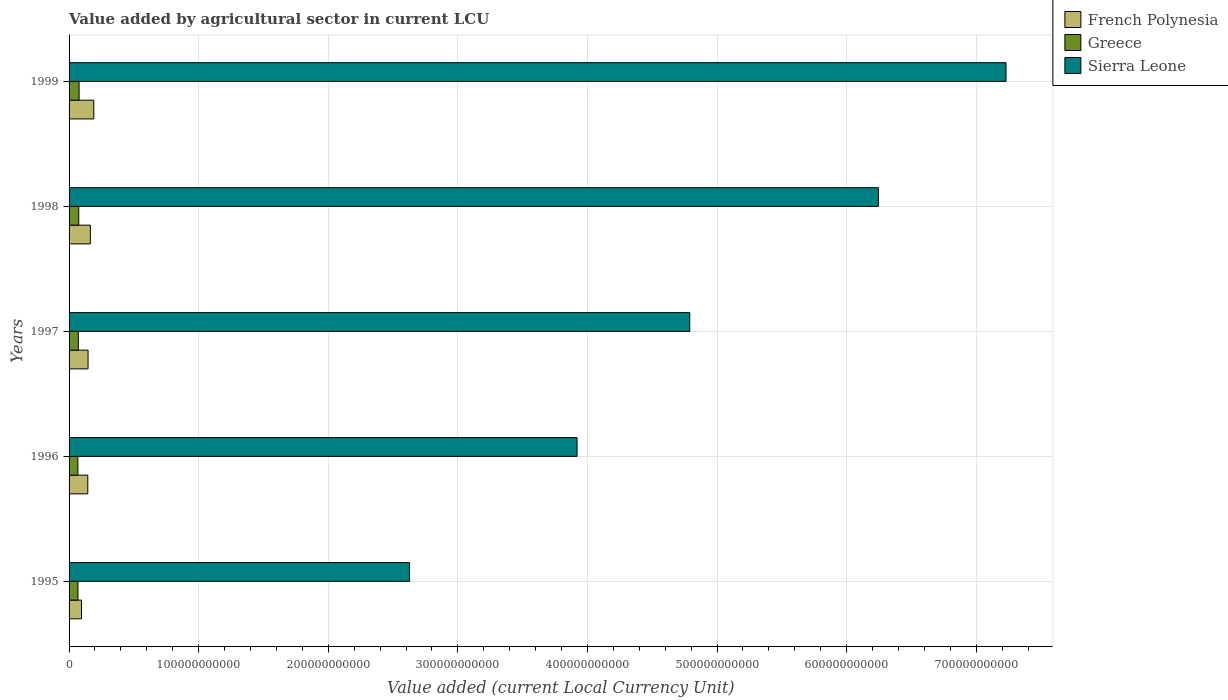Are the number of bars on each tick of the Y-axis equal?
Keep it short and to the point. Yes. How many bars are there on the 3rd tick from the bottom?
Your answer should be very brief. 3. What is the label of the 4th group of bars from the top?
Make the answer very short. 1996. In how many cases, is the number of bars for a given year not equal to the number of legend labels?
Provide a succinct answer. 0. What is the value added by agricultural sector in Greece in 1996?
Your answer should be compact. 6.78e+09. Across all years, what is the maximum value added by agricultural sector in Greece?
Your answer should be very brief. 7.74e+09. Across all years, what is the minimum value added by agricultural sector in Greece?
Keep it short and to the point. 6.78e+09. In which year was the value added by agricultural sector in Sierra Leone maximum?
Your response must be concise. 1999. In which year was the value added by agricultural sector in Greece minimum?
Your answer should be compact. 1996. What is the total value added by agricultural sector in Greece in the graph?
Give a very brief answer. 3.60e+1. What is the difference between the value added by agricultural sector in Greece in 1995 and that in 1997?
Ensure brevity in your answer.  -2.96e+08. What is the difference between the value added by agricultural sector in Greece in 1996 and the value added by agricultural sector in French Polynesia in 1998?
Your answer should be very brief. -9.64e+09. What is the average value added by agricultural sector in Greece per year?
Provide a succinct answer. 7.20e+09. In the year 1998, what is the difference between the value added by agricultural sector in Sierra Leone and value added by agricultural sector in French Polynesia?
Your answer should be very brief. 6.08e+11. What is the ratio of the value added by agricultural sector in Sierra Leone in 1996 to that in 1998?
Provide a succinct answer. 0.63. Is the difference between the value added by agricultural sector in Sierra Leone in 1996 and 1997 greater than the difference between the value added by agricultural sector in French Polynesia in 1996 and 1997?
Offer a terse response. No. What is the difference between the highest and the second highest value added by agricultural sector in Greece?
Your response must be concise. 2.66e+08. What is the difference between the highest and the lowest value added by agricultural sector in Sierra Leone?
Provide a succinct answer. 4.60e+11. Is the sum of the value added by agricultural sector in Greece in 1996 and 1999 greater than the maximum value added by agricultural sector in Sierra Leone across all years?
Ensure brevity in your answer.  No. What does the 3rd bar from the top in 1999 represents?
Your response must be concise. French Polynesia. What does the 1st bar from the bottom in 1997 represents?
Offer a terse response. French Polynesia. Is it the case that in every year, the sum of the value added by agricultural sector in French Polynesia and value added by agricultural sector in Greece is greater than the value added by agricultural sector in Sierra Leone?
Provide a succinct answer. No. Are all the bars in the graph horizontal?
Provide a succinct answer. Yes. How many years are there in the graph?
Provide a short and direct response. 5. What is the difference between two consecutive major ticks on the X-axis?
Make the answer very short. 1.00e+11. Are the values on the major ticks of X-axis written in scientific E-notation?
Your answer should be compact. No. Does the graph contain any zero values?
Ensure brevity in your answer.  No. Does the graph contain grids?
Your answer should be compact. Yes. Where does the legend appear in the graph?
Provide a succinct answer. Top right. What is the title of the graph?
Make the answer very short. Value added by agricultural sector in current LCU. What is the label or title of the X-axis?
Offer a terse response. Value added (current Local Currency Unit). What is the label or title of the Y-axis?
Offer a very short reply. Years. What is the Value added (current Local Currency Unit) in French Polynesia in 1995?
Offer a very short reply. 9.59e+09. What is the Value added (current Local Currency Unit) of Greece in 1995?
Offer a terse response. 6.86e+09. What is the Value added (current Local Currency Unit) of Sierra Leone in 1995?
Ensure brevity in your answer.  2.63e+11. What is the Value added (current Local Currency Unit) of French Polynesia in 1996?
Ensure brevity in your answer.  1.45e+1. What is the Value added (current Local Currency Unit) of Greece in 1996?
Provide a succinct answer. 6.78e+09. What is the Value added (current Local Currency Unit) of Sierra Leone in 1996?
Keep it short and to the point. 3.92e+11. What is the Value added (current Local Currency Unit) in French Polynesia in 1997?
Provide a succinct answer. 1.47e+1. What is the Value added (current Local Currency Unit) in Greece in 1997?
Provide a succinct answer. 7.16e+09. What is the Value added (current Local Currency Unit) of Sierra Leone in 1997?
Keep it short and to the point. 4.79e+11. What is the Value added (current Local Currency Unit) of French Polynesia in 1998?
Provide a short and direct response. 1.64e+1. What is the Value added (current Local Currency Unit) of Greece in 1998?
Keep it short and to the point. 7.47e+09. What is the Value added (current Local Currency Unit) in Sierra Leone in 1998?
Ensure brevity in your answer.  6.25e+11. What is the Value added (current Local Currency Unit) of French Polynesia in 1999?
Ensure brevity in your answer.  1.91e+1. What is the Value added (current Local Currency Unit) of Greece in 1999?
Your answer should be compact. 7.74e+09. What is the Value added (current Local Currency Unit) in Sierra Leone in 1999?
Keep it short and to the point. 7.23e+11. Across all years, what is the maximum Value added (current Local Currency Unit) of French Polynesia?
Your answer should be very brief. 1.91e+1. Across all years, what is the maximum Value added (current Local Currency Unit) of Greece?
Your answer should be compact. 7.74e+09. Across all years, what is the maximum Value added (current Local Currency Unit) in Sierra Leone?
Make the answer very short. 7.23e+11. Across all years, what is the minimum Value added (current Local Currency Unit) of French Polynesia?
Provide a short and direct response. 9.59e+09. Across all years, what is the minimum Value added (current Local Currency Unit) of Greece?
Give a very brief answer. 6.78e+09. Across all years, what is the minimum Value added (current Local Currency Unit) in Sierra Leone?
Your answer should be compact. 2.63e+11. What is the total Value added (current Local Currency Unit) of French Polynesia in the graph?
Ensure brevity in your answer.  7.42e+1. What is the total Value added (current Local Currency Unit) of Greece in the graph?
Offer a very short reply. 3.60e+1. What is the total Value added (current Local Currency Unit) of Sierra Leone in the graph?
Provide a short and direct response. 2.48e+12. What is the difference between the Value added (current Local Currency Unit) of French Polynesia in 1995 and that in 1996?
Provide a succinct answer. -4.86e+09. What is the difference between the Value added (current Local Currency Unit) of Greece in 1995 and that in 1996?
Provide a succinct answer. 7.93e+07. What is the difference between the Value added (current Local Currency Unit) of Sierra Leone in 1995 and that in 1996?
Your answer should be compact. -1.29e+11. What is the difference between the Value added (current Local Currency Unit) of French Polynesia in 1995 and that in 1997?
Make the answer very short. -5.07e+09. What is the difference between the Value added (current Local Currency Unit) in Greece in 1995 and that in 1997?
Make the answer very short. -2.96e+08. What is the difference between the Value added (current Local Currency Unit) of Sierra Leone in 1995 and that in 1997?
Give a very brief answer. -2.16e+11. What is the difference between the Value added (current Local Currency Unit) in French Polynesia in 1995 and that in 1998?
Give a very brief answer. -6.84e+09. What is the difference between the Value added (current Local Currency Unit) of Greece in 1995 and that in 1998?
Ensure brevity in your answer.  -6.08e+08. What is the difference between the Value added (current Local Currency Unit) in Sierra Leone in 1995 and that in 1998?
Your answer should be very brief. -3.62e+11. What is the difference between the Value added (current Local Currency Unit) in French Polynesia in 1995 and that in 1999?
Give a very brief answer. -9.51e+09. What is the difference between the Value added (current Local Currency Unit) in Greece in 1995 and that in 1999?
Offer a terse response. -8.73e+08. What is the difference between the Value added (current Local Currency Unit) in Sierra Leone in 1995 and that in 1999?
Offer a very short reply. -4.60e+11. What is the difference between the Value added (current Local Currency Unit) in French Polynesia in 1996 and that in 1997?
Keep it short and to the point. -2.05e+08. What is the difference between the Value added (current Local Currency Unit) in Greece in 1996 and that in 1997?
Your answer should be compact. -3.75e+08. What is the difference between the Value added (current Local Currency Unit) in Sierra Leone in 1996 and that in 1997?
Your answer should be compact. -8.70e+1. What is the difference between the Value added (current Local Currency Unit) of French Polynesia in 1996 and that in 1998?
Make the answer very short. -1.98e+09. What is the difference between the Value added (current Local Currency Unit) of Greece in 1996 and that in 1998?
Provide a short and direct response. -6.87e+08. What is the difference between the Value added (current Local Currency Unit) in Sierra Leone in 1996 and that in 1998?
Your answer should be compact. -2.33e+11. What is the difference between the Value added (current Local Currency Unit) of French Polynesia in 1996 and that in 1999?
Give a very brief answer. -4.65e+09. What is the difference between the Value added (current Local Currency Unit) of Greece in 1996 and that in 1999?
Ensure brevity in your answer.  -9.53e+08. What is the difference between the Value added (current Local Currency Unit) of Sierra Leone in 1996 and that in 1999?
Your response must be concise. -3.31e+11. What is the difference between the Value added (current Local Currency Unit) of French Polynesia in 1997 and that in 1998?
Keep it short and to the point. -1.77e+09. What is the difference between the Value added (current Local Currency Unit) in Greece in 1997 and that in 1998?
Offer a terse response. -3.12e+08. What is the difference between the Value added (current Local Currency Unit) of Sierra Leone in 1997 and that in 1998?
Provide a succinct answer. -1.46e+11. What is the difference between the Value added (current Local Currency Unit) in French Polynesia in 1997 and that in 1999?
Give a very brief answer. -4.44e+09. What is the difference between the Value added (current Local Currency Unit) in Greece in 1997 and that in 1999?
Provide a short and direct response. -5.78e+08. What is the difference between the Value added (current Local Currency Unit) in Sierra Leone in 1997 and that in 1999?
Provide a short and direct response. -2.44e+11. What is the difference between the Value added (current Local Currency Unit) of French Polynesia in 1998 and that in 1999?
Offer a very short reply. -2.67e+09. What is the difference between the Value added (current Local Currency Unit) of Greece in 1998 and that in 1999?
Your answer should be compact. -2.66e+08. What is the difference between the Value added (current Local Currency Unit) in Sierra Leone in 1998 and that in 1999?
Your response must be concise. -9.85e+1. What is the difference between the Value added (current Local Currency Unit) of French Polynesia in 1995 and the Value added (current Local Currency Unit) of Greece in 1996?
Provide a short and direct response. 2.81e+09. What is the difference between the Value added (current Local Currency Unit) of French Polynesia in 1995 and the Value added (current Local Currency Unit) of Sierra Leone in 1996?
Provide a succinct answer. -3.82e+11. What is the difference between the Value added (current Local Currency Unit) in Greece in 1995 and the Value added (current Local Currency Unit) in Sierra Leone in 1996?
Ensure brevity in your answer.  -3.85e+11. What is the difference between the Value added (current Local Currency Unit) in French Polynesia in 1995 and the Value added (current Local Currency Unit) in Greece in 1997?
Your response must be concise. 2.43e+09. What is the difference between the Value added (current Local Currency Unit) of French Polynesia in 1995 and the Value added (current Local Currency Unit) of Sierra Leone in 1997?
Give a very brief answer. -4.69e+11. What is the difference between the Value added (current Local Currency Unit) in Greece in 1995 and the Value added (current Local Currency Unit) in Sierra Leone in 1997?
Give a very brief answer. -4.72e+11. What is the difference between the Value added (current Local Currency Unit) in French Polynesia in 1995 and the Value added (current Local Currency Unit) in Greece in 1998?
Provide a succinct answer. 2.12e+09. What is the difference between the Value added (current Local Currency Unit) in French Polynesia in 1995 and the Value added (current Local Currency Unit) in Sierra Leone in 1998?
Keep it short and to the point. -6.15e+11. What is the difference between the Value added (current Local Currency Unit) in Greece in 1995 and the Value added (current Local Currency Unit) in Sierra Leone in 1998?
Give a very brief answer. -6.18e+11. What is the difference between the Value added (current Local Currency Unit) of French Polynesia in 1995 and the Value added (current Local Currency Unit) of Greece in 1999?
Offer a very short reply. 1.85e+09. What is the difference between the Value added (current Local Currency Unit) in French Polynesia in 1995 and the Value added (current Local Currency Unit) in Sierra Leone in 1999?
Your response must be concise. -7.13e+11. What is the difference between the Value added (current Local Currency Unit) of Greece in 1995 and the Value added (current Local Currency Unit) of Sierra Leone in 1999?
Your answer should be compact. -7.16e+11. What is the difference between the Value added (current Local Currency Unit) of French Polynesia in 1996 and the Value added (current Local Currency Unit) of Greece in 1997?
Offer a very short reply. 7.29e+09. What is the difference between the Value added (current Local Currency Unit) in French Polynesia in 1996 and the Value added (current Local Currency Unit) in Sierra Leone in 1997?
Your response must be concise. -4.65e+11. What is the difference between the Value added (current Local Currency Unit) in Greece in 1996 and the Value added (current Local Currency Unit) in Sierra Leone in 1997?
Offer a terse response. -4.72e+11. What is the difference between the Value added (current Local Currency Unit) in French Polynesia in 1996 and the Value added (current Local Currency Unit) in Greece in 1998?
Provide a short and direct response. 6.98e+09. What is the difference between the Value added (current Local Currency Unit) of French Polynesia in 1996 and the Value added (current Local Currency Unit) of Sierra Leone in 1998?
Offer a very short reply. -6.10e+11. What is the difference between the Value added (current Local Currency Unit) of Greece in 1996 and the Value added (current Local Currency Unit) of Sierra Leone in 1998?
Your answer should be very brief. -6.18e+11. What is the difference between the Value added (current Local Currency Unit) in French Polynesia in 1996 and the Value added (current Local Currency Unit) in Greece in 1999?
Provide a short and direct response. 6.72e+09. What is the difference between the Value added (current Local Currency Unit) of French Polynesia in 1996 and the Value added (current Local Currency Unit) of Sierra Leone in 1999?
Make the answer very short. -7.09e+11. What is the difference between the Value added (current Local Currency Unit) of Greece in 1996 and the Value added (current Local Currency Unit) of Sierra Leone in 1999?
Your answer should be very brief. -7.16e+11. What is the difference between the Value added (current Local Currency Unit) in French Polynesia in 1997 and the Value added (current Local Currency Unit) in Greece in 1998?
Ensure brevity in your answer.  7.19e+09. What is the difference between the Value added (current Local Currency Unit) in French Polynesia in 1997 and the Value added (current Local Currency Unit) in Sierra Leone in 1998?
Ensure brevity in your answer.  -6.10e+11. What is the difference between the Value added (current Local Currency Unit) in Greece in 1997 and the Value added (current Local Currency Unit) in Sierra Leone in 1998?
Your answer should be compact. -6.17e+11. What is the difference between the Value added (current Local Currency Unit) in French Polynesia in 1997 and the Value added (current Local Currency Unit) in Greece in 1999?
Your response must be concise. 6.92e+09. What is the difference between the Value added (current Local Currency Unit) of French Polynesia in 1997 and the Value added (current Local Currency Unit) of Sierra Leone in 1999?
Provide a succinct answer. -7.08e+11. What is the difference between the Value added (current Local Currency Unit) of Greece in 1997 and the Value added (current Local Currency Unit) of Sierra Leone in 1999?
Make the answer very short. -7.16e+11. What is the difference between the Value added (current Local Currency Unit) in French Polynesia in 1998 and the Value added (current Local Currency Unit) in Greece in 1999?
Offer a terse response. 8.69e+09. What is the difference between the Value added (current Local Currency Unit) of French Polynesia in 1998 and the Value added (current Local Currency Unit) of Sierra Leone in 1999?
Ensure brevity in your answer.  -7.07e+11. What is the difference between the Value added (current Local Currency Unit) of Greece in 1998 and the Value added (current Local Currency Unit) of Sierra Leone in 1999?
Provide a short and direct response. -7.16e+11. What is the average Value added (current Local Currency Unit) of French Polynesia per year?
Ensure brevity in your answer.  1.48e+1. What is the average Value added (current Local Currency Unit) in Greece per year?
Give a very brief answer. 7.20e+09. What is the average Value added (current Local Currency Unit) of Sierra Leone per year?
Your answer should be compact. 4.96e+11. In the year 1995, what is the difference between the Value added (current Local Currency Unit) in French Polynesia and Value added (current Local Currency Unit) in Greece?
Offer a terse response. 2.73e+09. In the year 1995, what is the difference between the Value added (current Local Currency Unit) of French Polynesia and Value added (current Local Currency Unit) of Sierra Leone?
Your answer should be very brief. -2.53e+11. In the year 1995, what is the difference between the Value added (current Local Currency Unit) in Greece and Value added (current Local Currency Unit) in Sierra Leone?
Offer a terse response. -2.56e+11. In the year 1996, what is the difference between the Value added (current Local Currency Unit) of French Polynesia and Value added (current Local Currency Unit) of Greece?
Offer a terse response. 7.67e+09. In the year 1996, what is the difference between the Value added (current Local Currency Unit) in French Polynesia and Value added (current Local Currency Unit) in Sierra Leone?
Your answer should be compact. -3.78e+11. In the year 1996, what is the difference between the Value added (current Local Currency Unit) in Greece and Value added (current Local Currency Unit) in Sierra Leone?
Keep it short and to the point. -3.85e+11. In the year 1997, what is the difference between the Value added (current Local Currency Unit) in French Polynesia and Value added (current Local Currency Unit) in Greece?
Provide a succinct answer. 7.50e+09. In the year 1997, what is the difference between the Value added (current Local Currency Unit) of French Polynesia and Value added (current Local Currency Unit) of Sierra Leone?
Offer a terse response. -4.64e+11. In the year 1997, what is the difference between the Value added (current Local Currency Unit) in Greece and Value added (current Local Currency Unit) in Sierra Leone?
Offer a very short reply. -4.72e+11. In the year 1998, what is the difference between the Value added (current Local Currency Unit) of French Polynesia and Value added (current Local Currency Unit) of Greece?
Offer a terse response. 8.96e+09. In the year 1998, what is the difference between the Value added (current Local Currency Unit) of French Polynesia and Value added (current Local Currency Unit) of Sierra Leone?
Make the answer very short. -6.08e+11. In the year 1998, what is the difference between the Value added (current Local Currency Unit) of Greece and Value added (current Local Currency Unit) of Sierra Leone?
Your answer should be very brief. -6.17e+11. In the year 1999, what is the difference between the Value added (current Local Currency Unit) in French Polynesia and Value added (current Local Currency Unit) in Greece?
Your answer should be compact. 1.14e+1. In the year 1999, what is the difference between the Value added (current Local Currency Unit) in French Polynesia and Value added (current Local Currency Unit) in Sierra Leone?
Your answer should be very brief. -7.04e+11. In the year 1999, what is the difference between the Value added (current Local Currency Unit) in Greece and Value added (current Local Currency Unit) in Sierra Leone?
Offer a very short reply. -7.15e+11. What is the ratio of the Value added (current Local Currency Unit) in French Polynesia in 1995 to that in 1996?
Provide a succinct answer. 0.66. What is the ratio of the Value added (current Local Currency Unit) in Greece in 1995 to that in 1996?
Provide a short and direct response. 1.01. What is the ratio of the Value added (current Local Currency Unit) in Sierra Leone in 1995 to that in 1996?
Your response must be concise. 0.67. What is the ratio of the Value added (current Local Currency Unit) of French Polynesia in 1995 to that in 1997?
Offer a very short reply. 0.65. What is the ratio of the Value added (current Local Currency Unit) of Greece in 1995 to that in 1997?
Offer a terse response. 0.96. What is the ratio of the Value added (current Local Currency Unit) in Sierra Leone in 1995 to that in 1997?
Offer a terse response. 0.55. What is the ratio of the Value added (current Local Currency Unit) of French Polynesia in 1995 to that in 1998?
Make the answer very short. 0.58. What is the ratio of the Value added (current Local Currency Unit) of Greece in 1995 to that in 1998?
Offer a very short reply. 0.92. What is the ratio of the Value added (current Local Currency Unit) of Sierra Leone in 1995 to that in 1998?
Keep it short and to the point. 0.42. What is the ratio of the Value added (current Local Currency Unit) in French Polynesia in 1995 to that in 1999?
Provide a short and direct response. 0.5. What is the ratio of the Value added (current Local Currency Unit) in Greece in 1995 to that in 1999?
Ensure brevity in your answer.  0.89. What is the ratio of the Value added (current Local Currency Unit) in Sierra Leone in 1995 to that in 1999?
Give a very brief answer. 0.36. What is the ratio of the Value added (current Local Currency Unit) of French Polynesia in 1996 to that in 1997?
Your response must be concise. 0.99. What is the ratio of the Value added (current Local Currency Unit) in Greece in 1996 to that in 1997?
Your answer should be compact. 0.95. What is the ratio of the Value added (current Local Currency Unit) in Sierra Leone in 1996 to that in 1997?
Offer a terse response. 0.82. What is the ratio of the Value added (current Local Currency Unit) in French Polynesia in 1996 to that in 1998?
Keep it short and to the point. 0.88. What is the ratio of the Value added (current Local Currency Unit) in Greece in 1996 to that in 1998?
Keep it short and to the point. 0.91. What is the ratio of the Value added (current Local Currency Unit) in Sierra Leone in 1996 to that in 1998?
Ensure brevity in your answer.  0.63. What is the ratio of the Value added (current Local Currency Unit) of French Polynesia in 1996 to that in 1999?
Make the answer very short. 0.76. What is the ratio of the Value added (current Local Currency Unit) of Greece in 1996 to that in 1999?
Ensure brevity in your answer.  0.88. What is the ratio of the Value added (current Local Currency Unit) in Sierra Leone in 1996 to that in 1999?
Your answer should be compact. 0.54. What is the ratio of the Value added (current Local Currency Unit) in French Polynesia in 1997 to that in 1998?
Your answer should be very brief. 0.89. What is the ratio of the Value added (current Local Currency Unit) of Greece in 1997 to that in 1998?
Offer a terse response. 0.96. What is the ratio of the Value added (current Local Currency Unit) of Sierra Leone in 1997 to that in 1998?
Provide a short and direct response. 0.77. What is the ratio of the Value added (current Local Currency Unit) in French Polynesia in 1997 to that in 1999?
Your answer should be very brief. 0.77. What is the ratio of the Value added (current Local Currency Unit) in Greece in 1997 to that in 1999?
Ensure brevity in your answer.  0.93. What is the ratio of the Value added (current Local Currency Unit) in Sierra Leone in 1997 to that in 1999?
Provide a short and direct response. 0.66. What is the ratio of the Value added (current Local Currency Unit) of French Polynesia in 1998 to that in 1999?
Your answer should be compact. 0.86. What is the ratio of the Value added (current Local Currency Unit) in Greece in 1998 to that in 1999?
Keep it short and to the point. 0.97. What is the ratio of the Value added (current Local Currency Unit) of Sierra Leone in 1998 to that in 1999?
Your response must be concise. 0.86. What is the difference between the highest and the second highest Value added (current Local Currency Unit) of French Polynesia?
Provide a short and direct response. 2.67e+09. What is the difference between the highest and the second highest Value added (current Local Currency Unit) in Greece?
Give a very brief answer. 2.66e+08. What is the difference between the highest and the second highest Value added (current Local Currency Unit) in Sierra Leone?
Make the answer very short. 9.85e+1. What is the difference between the highest and the lowest Value added (current Local Currency Unit) in French Polynesia?
Offer a terse response. 9.51e+09. What is the difference between the highest and the lowest Value added (current Local Currency Unit) of Greece?
Keep it short and to the point. 9.53e+08. What is the difference between the highest and the lowest Value added (current Local Currency Unit) in Sierra Leone?
Offer a very short reply. 4.60e+11. 